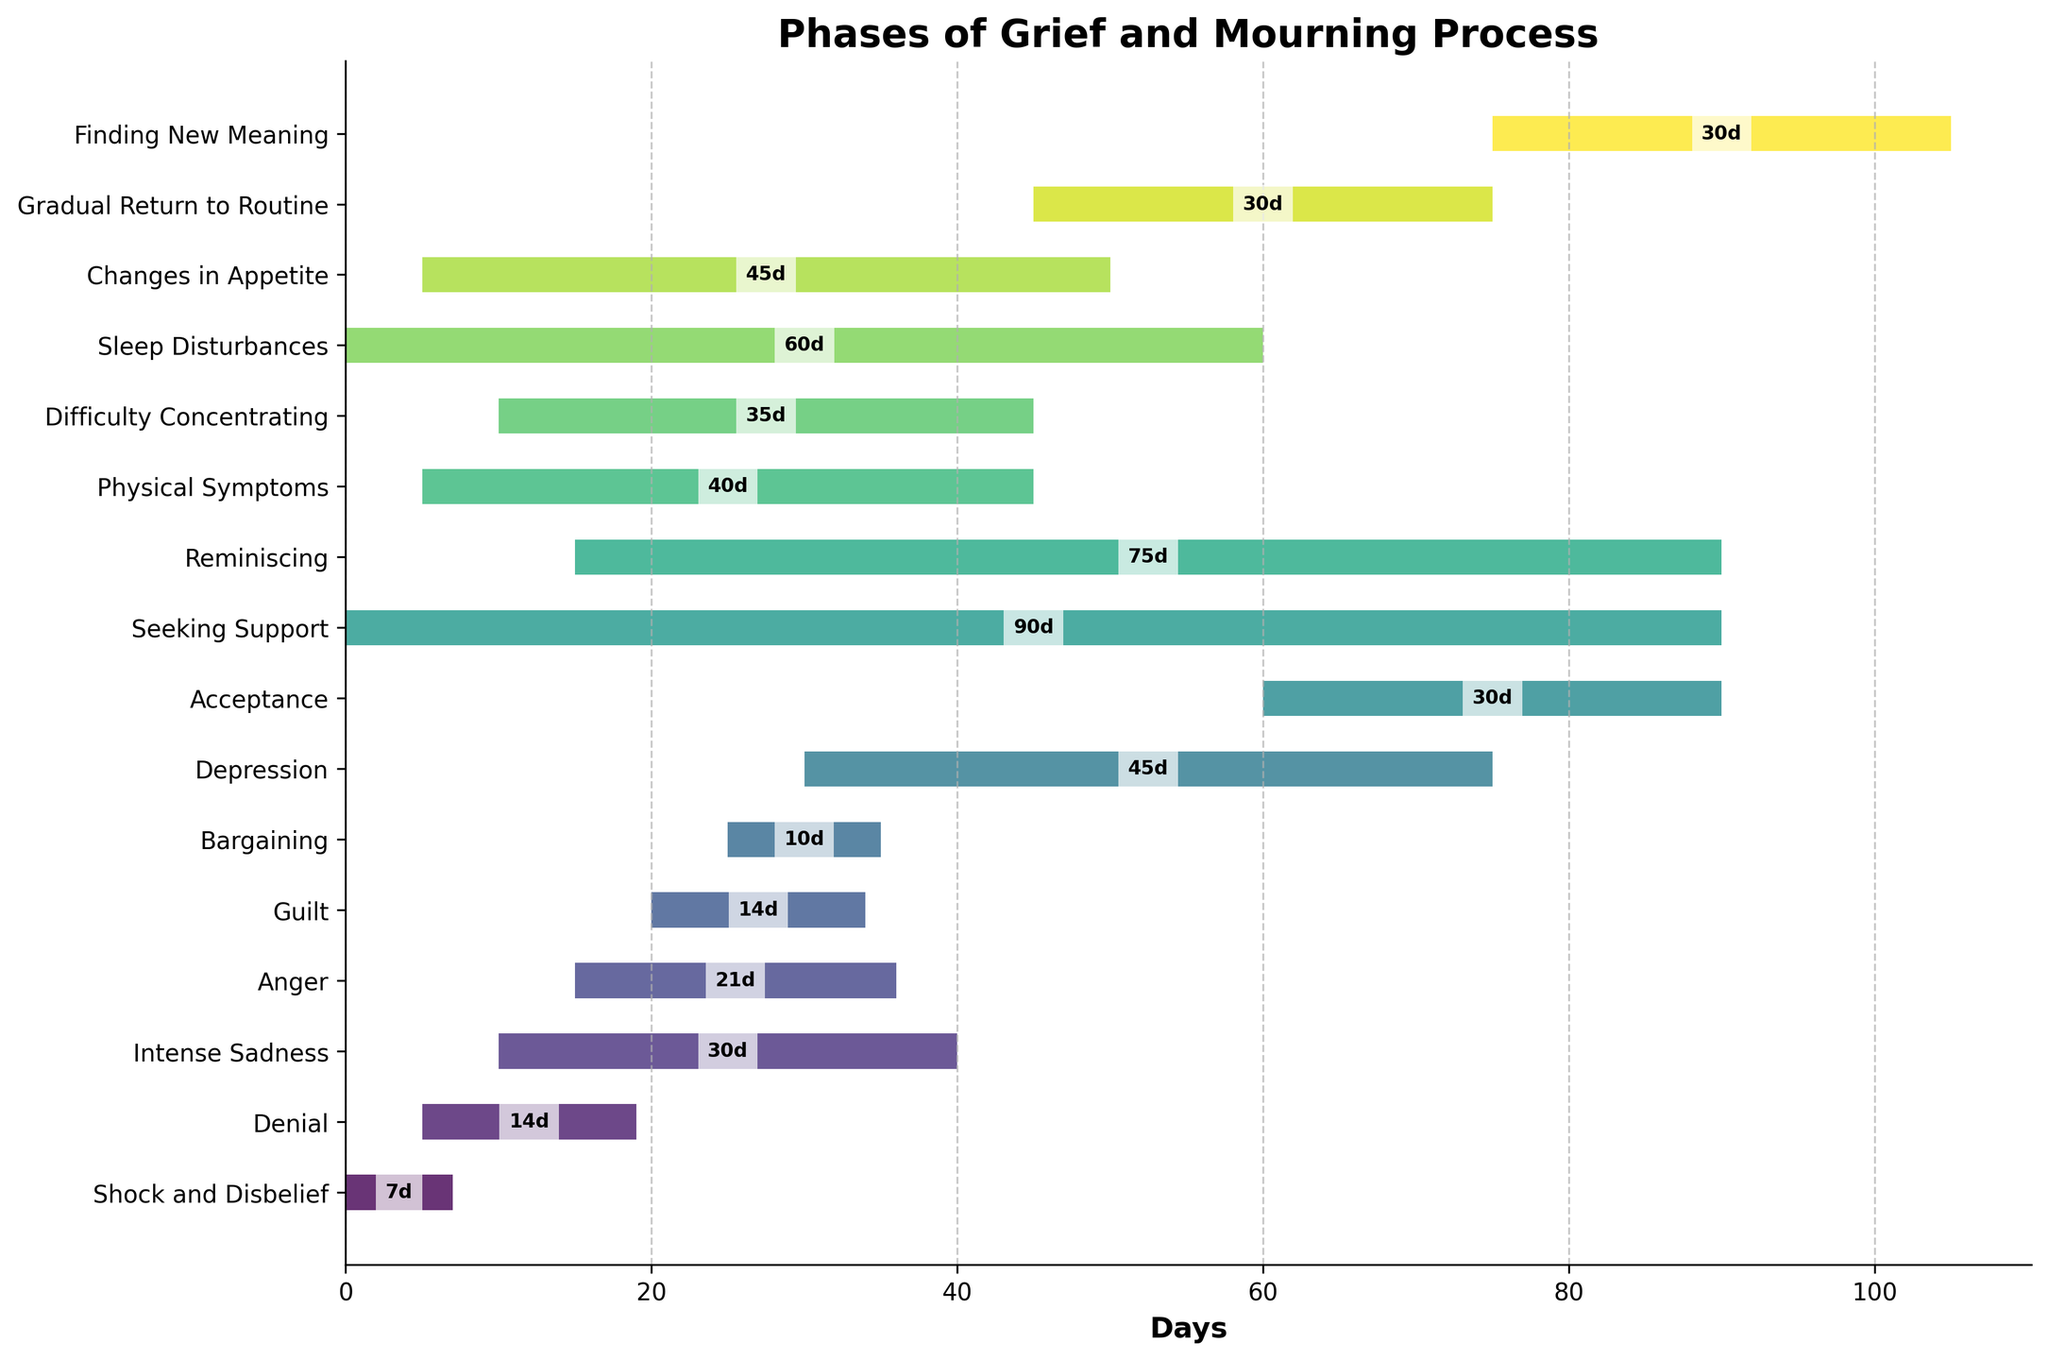What is the title of the chart? The title of the chart is located at the top of the figure in bold. It reads: "Phases of Grief and Mourning Process."
Answer: Phases of Grief and Mourning Process How many phases are visualized in the chart? By counting the number of horizontal bars representing different phases on the chart, we can determine the total number of phases.
Answer: 16 Which phase starts first, and how long does it last? The phase that starts first is the one with the leftmost position on the horizontal axis and starts at day 0. The duration of this phase can be read off the chart.
Answer: Shock and Disbelief, 7 days Which phase ends last? The phase that ends last is the one with the rightmost endpoint on the horizontal axis. By checking the ending points of all phases, we can identify the longest-lasting phase.
Answer: Seeking Support How long after the start of 'Shock and Disbelief' does 'Acceptance' begin? By looking at the start days of 'Shock and Disbelief' and 'Acceptance,' we determine the difference between their start times. 'Acceptance' starts on day 60, while 'Shock and Disbelief' starts on day 0. Subtract day 0 from day 60.
Answer: 60 days Which two phases overlap for the longest duration? By visual inspection, check for phases with overlapping bars and compare the duration of overlaps.
Answer: Reminiscing and Seeking Support What phase is active for the shortest duration, and how many days is it active? By examining the duration of each phase from the chart, identify the phase with the shortest bar length representing duration.
Answer: Bargaining, 10 days How long is the overlap between 'Anger' and 'Physical Symptoms’? 'Anger' starts at day 15 and lasts 21 days (ending at day 36). 'Physical Symptoms' starts at day 5 and lasts 40 days (ending at day 45). Their overlap is the intersection of [15, 36] and [5, 45], which is from day 15 to day 36. This duration is 36 - 15 = 21 days.
Answer: 21 days What is the total duration of phases that involve experiencing emotional turmoil ('Intense Sadness', 'Anger', and 'Depression')? By adding the durations of 'Intense Sadness', 'Anger', and 'Depression' directly from the chart: 30 days + 21 days + 45 days = 96 days.
Answer: 96 days Which phase starts at the same time as 'Shock and Disbelief' and how long does it last? By looking at the start day column, identify the phase that starts at day 0 and determine its duration. 'Seeking Support' also starts at day 0 and lasts for 90 days as shown on the chart.
Answer: Seeking Support, 90 days 